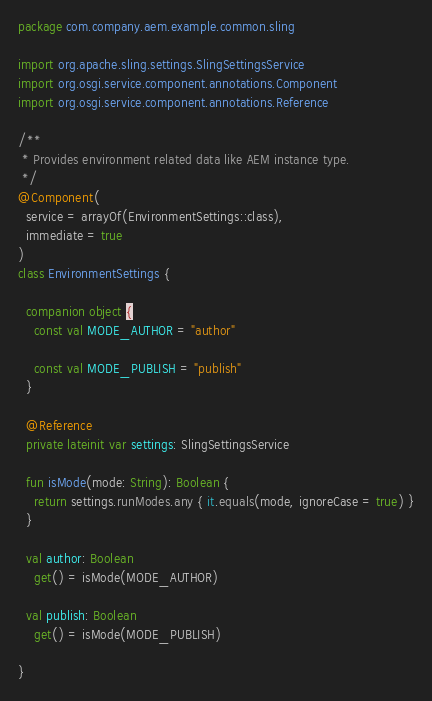Convert code to text. <code><loc_0><loc_0><loc_500><loc_500><_Kotlin_>package com.company.aem.example.common.sling

import org.apache.sling.settings.SlingSettingsService
import org.osgi.service.component.annotations.Component
import org.osgi.service.component.annotations.Reference

/**
 * Provides environment related data like AEM instance type.
 */
@Component(
  service = arrayOf(EnvironmentSettings::class),
  immediate = true
)
class EnvironmentSettings {

  companion object {
    const val MODE_AUTHOR = "author"

    const val MODE_PUBLISH = "publish"
  }

  @Reference
  private lateinit var settings: SlingSettingsService

  fun isMode(mode: String): Boolean {
    return settings.runModes.any { it.equals(mode, ignoreCase = true) }
  }

  val author: Boolean
    get() = isMode(MODE_AUTHOR)

  val publish: Boolean
    get() = isMode(MODE_PUBLISH)

}
</code> 